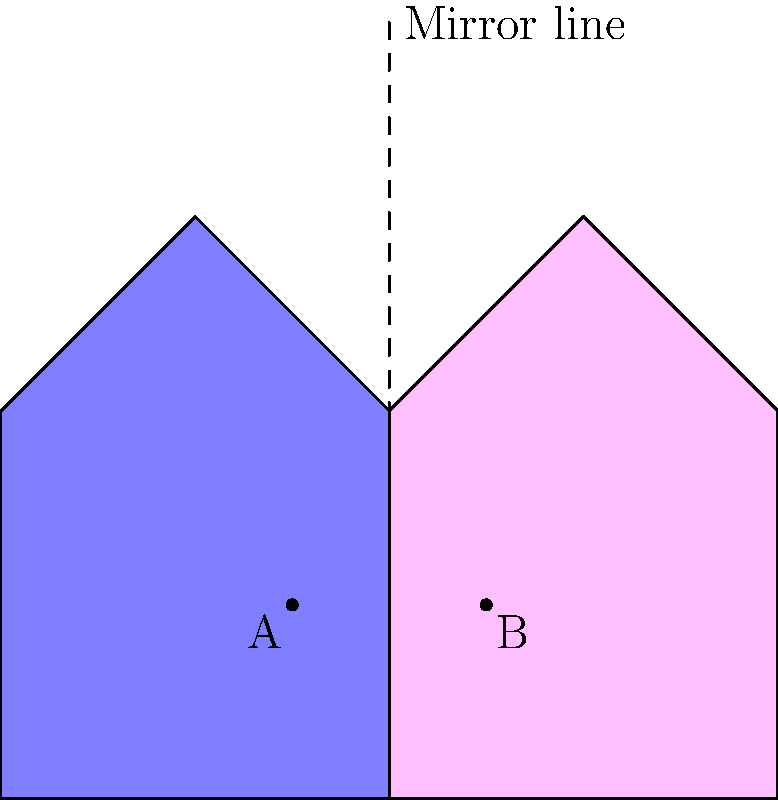In the image above, two asymmetrical shapes are shown on either side of a mirror line. Point A is marked on the blue shape. Which point on the pink shape corresponds to the mirror image of point A? To identify the mirror image of point A, we need to follow these steps:

1. Understand the concept of mirror images: In a mirror reflection, each point of the original shape is reflected across the mirror line to create the image.

2. Locate the mirror line: In this diagram, the mirror line is the dashed vertical line in the center.

3. Identify point A: Point A is located on the blue shape, slightly to the left and below the center.

4. Find the corresponding point on the pink shape: To do this, we need to:
   a. Mentally draw a line from point A perpendicular to the mirror line.
   b. Extend this line the same distance on the other side of the mirror line.
   c. The point where this extended line ends on the pink shape is the mirror image of point A.

5. Verify the result: The point we found in step 4 should be in a similar position on the pink shape as point A is on the blue shape, but mirrored.

6. Identify the label: The point we found is labeled as B on the pink shape.

This process of mental reflection is important in spatial reasoning and can be relevant in aphasia treatment, where patients might need to practice visual-spatial tasks to improve their cognitive abilities.
Answer: B 